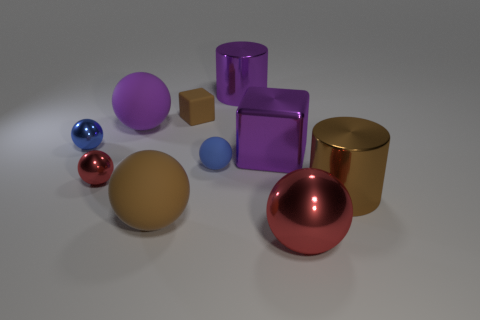Are there more glossy objects or matte objects in this scene? In this scene, there are more glossy objects. The three spheres, the two cylinders, and the clear purple cube have a shiny appearance indicating a glossy finish. The matte objects are the opaque purple cube and the small brown block. 